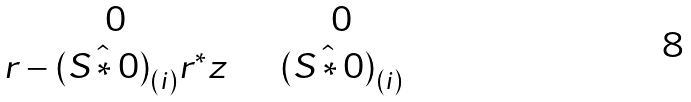<formula> <loc_0><loc_0><loc_500><loc_500>\begin{matrix} 0 & \quad 0 \\ r - \hat { ( S * 0 ) } _ { ( i ) } r ^ { * } z & \quad \hat { ( S * 0 ) } _ { ( i ) } \end{matrix}</formula> 